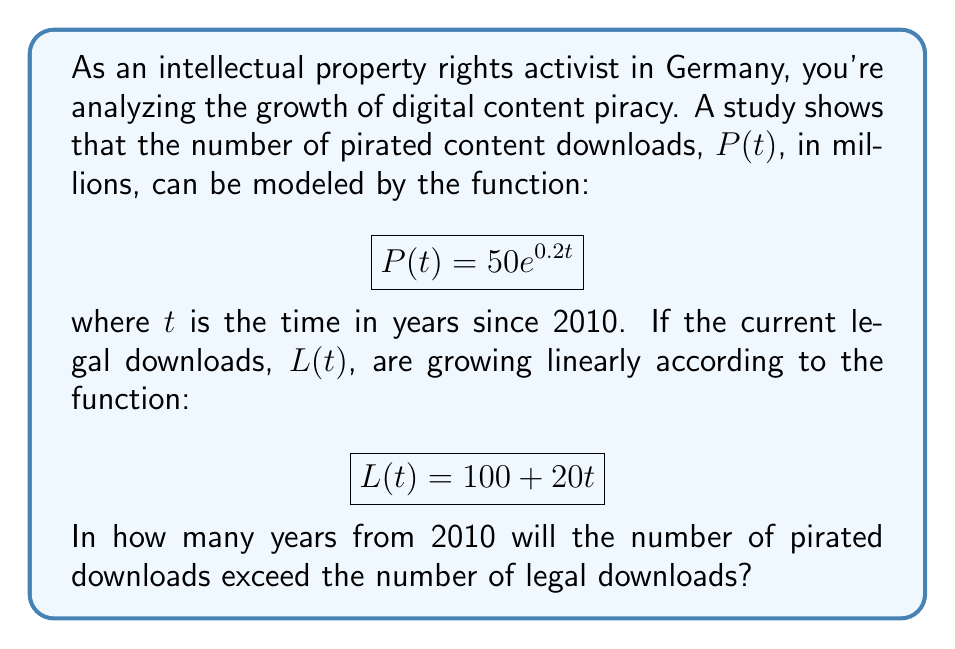Help me with this question. To solve this problem, we need to find the point where $P(t) = L(t)$. Let's approach this step-by-step:

1) We have two equations:
   $$P(t) = 50e^{0.2t}$$
   $$L(t) = 100 + 20t$$

2) We want to find $t$ when $P(t) = L(t)$:
   $$50e^{0.2t} = 100 + 20t$$

3) This is a transcendental equation that can't be solved algebraically. We need to use numerical methods or graphing to solve it.

4) Let's define a new function $f(t)$:
   $$f(t) = 50e^{0.2t} - (100 + 20t)$$

5) We're looking for the root of this function. We can use a graphing calculator or software to find where $f(t) = 0$.

6) Using a graphing tool, we find that $f(t) = 0$ when $t \approx 8.34$.

7) Since $t$ represents years since 2010, and we need to round up to the nearest whole year, the answer is 9 years.

This means that in 2019 (9 years after 2010), the number of pirated downloads will exceed the number of legal downloads.
Answer: 9 years 